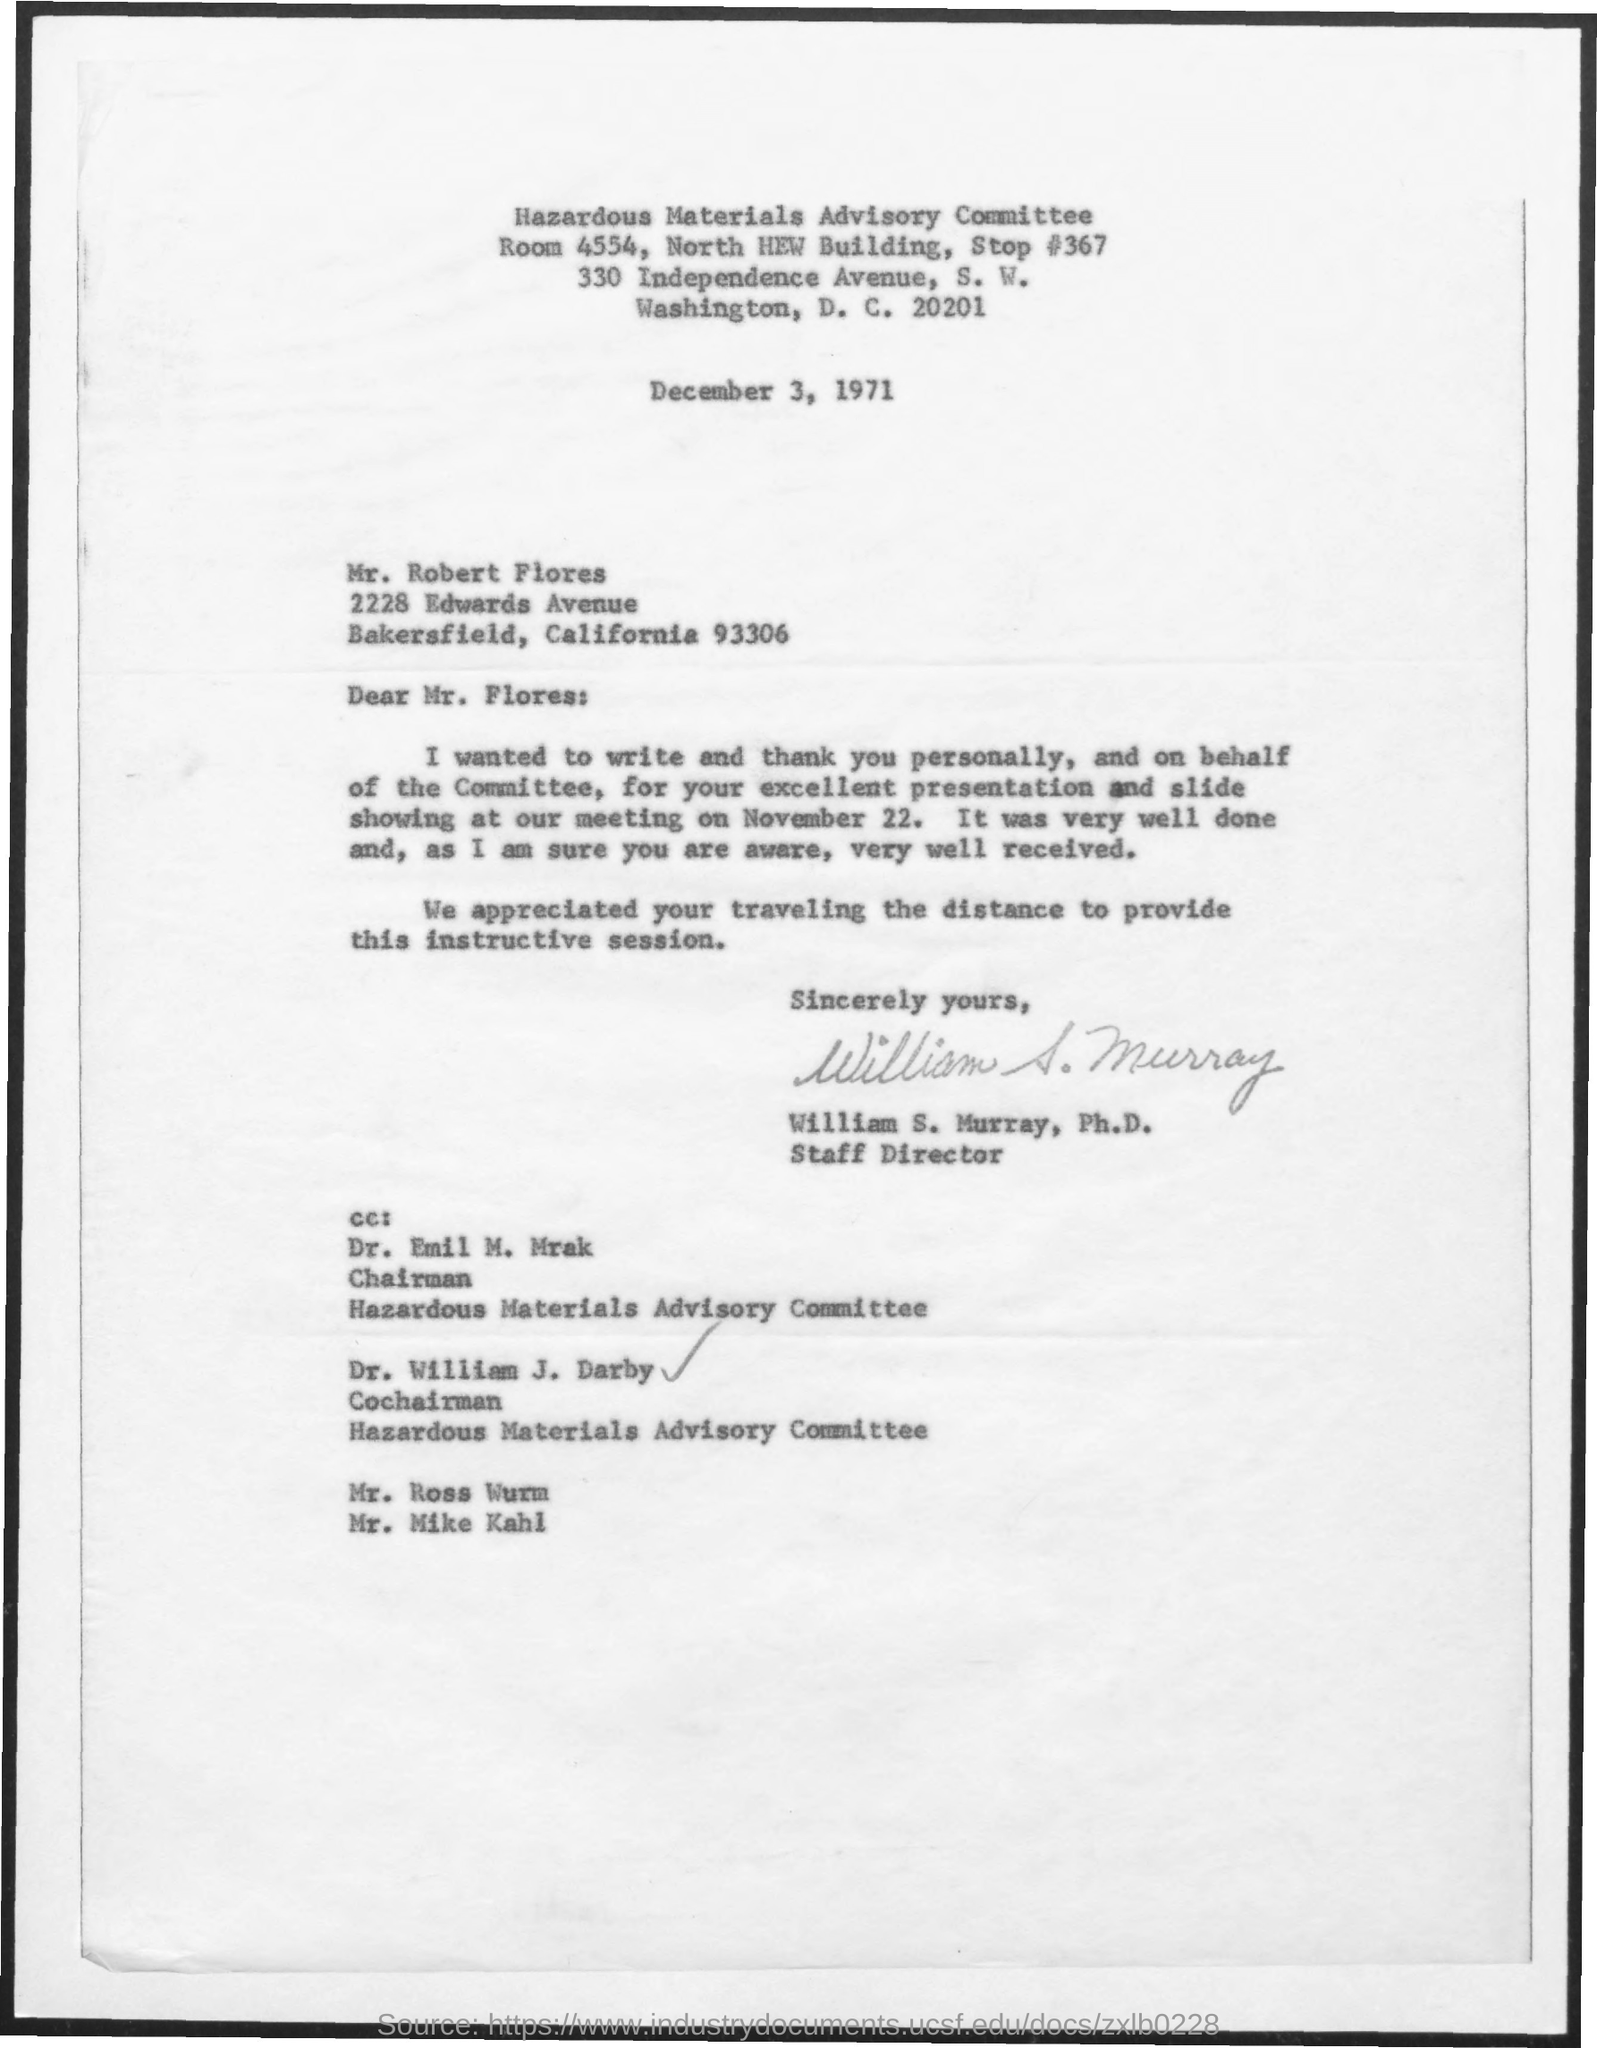What is the committee name?
Make the answer very short. Hazardous Materials Advisory Committee. What is the date on the letter?
Make the answer very short. December 3, 1971. To whom is the letter addressed to?
Offer a terse response. Mr. Robert Flores. Who is the sender of the letter?
Provide a short and direct response. William S. Murray, Ph.D. What is the designation of william s. murray?
Provide a succinct answer. Staff Director. What is the designation of Dr. Emil M. Mrak?
Offer a terse response. Chairman. What is the designation of Dr. William J. Darby?
Provide a succinct answer. Cochairman. 